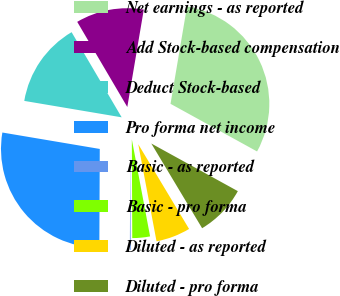<chart> <loc_0><loc_0><loc_500><loc_500><pie_chart><fcel>Net earnings - as reported<fcel>Add Stock-based compensation<fcel>Deduct Stock-based<fcel>Pro forma net income<fcel>Basic - as reported<fcel>Basic - pro forma<fcel>Diluted - as reported<fcel>Diluted - pro forma<nl><fcel>30.34%<fcel>11.13%<fcel>13.88%<fcel>27.59%<fcel>0.14%<fcel>2.89%<fcel>5.64%<fcel>8.39%<nl></chart> 